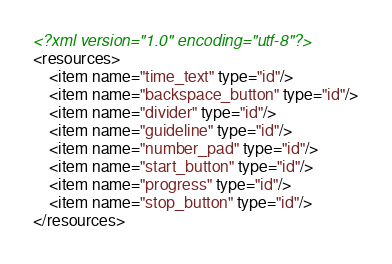Convert code to text. <code><loc_0><loc_0><loc_500><loc_500><_XML_><?xml version="1.0" encoding="utf-8"?>
<resources>
    <item name="time_text" type="id"/>
    <item name="backspace_button" type="id"/>
    <item name="divider" type="id"/>
    <item name="guideline" type="id"/>
    <item name="number_pad" type="id"/>
    <item name="start_button" type="id"/>
    <item name="progress" type="id"/>
    <item name="stop_button" type="id"/>
</resources>
</code> 